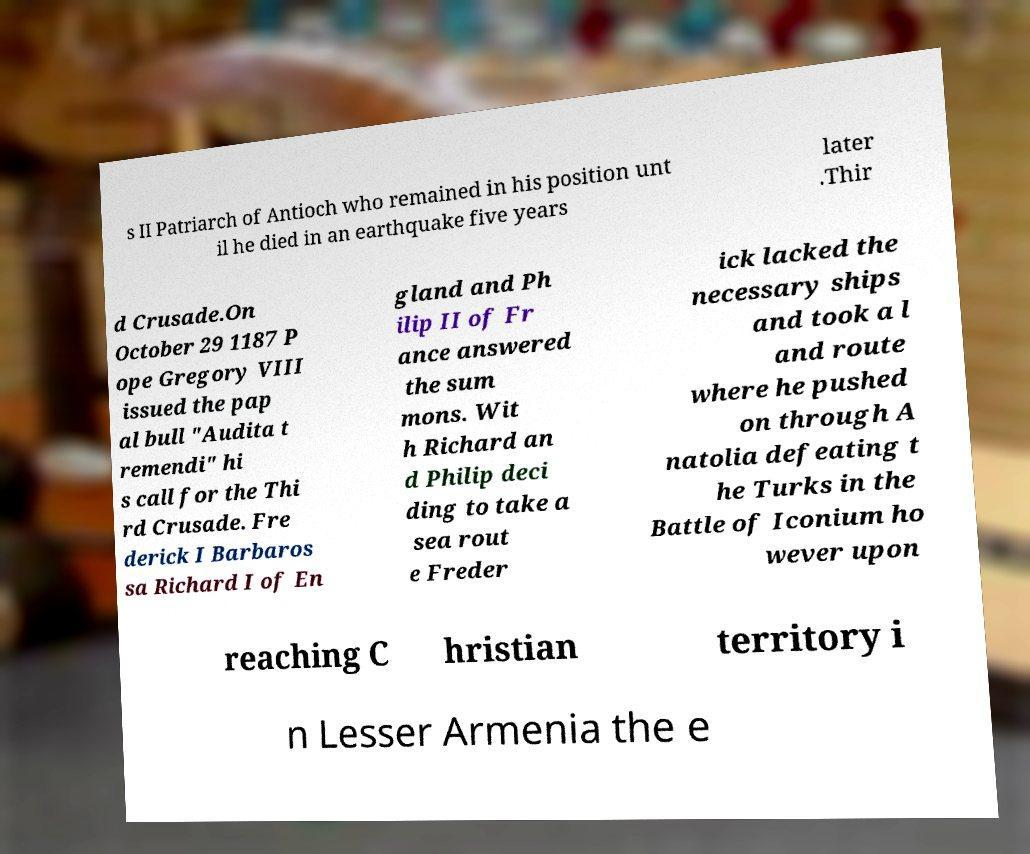For documentation purposes, I need the text within this image transcribed. Could you provide that? s II Patriarch of Antioch who remained in his position unt il he died in an earthquake five years later .Thir d Crusade.On October 29 1187 P ope Gregory VIII issued the pap al bull "Audita t remendi" hi s call for the Thi rd Crusade. Fre derick I Barbaros sa Richard I of En gland and Ph ilip II of Fr ance answered the sum mons. Wit h Richard an d Philip deci ding to take a sea rout e Freder ick lacked the necessary ships and took a l and route where he pushed on through A natolia defeating t he Turks in the Battle of Iconium ho wever upon reaching C hristian territory i n Lesser Armenia the e 